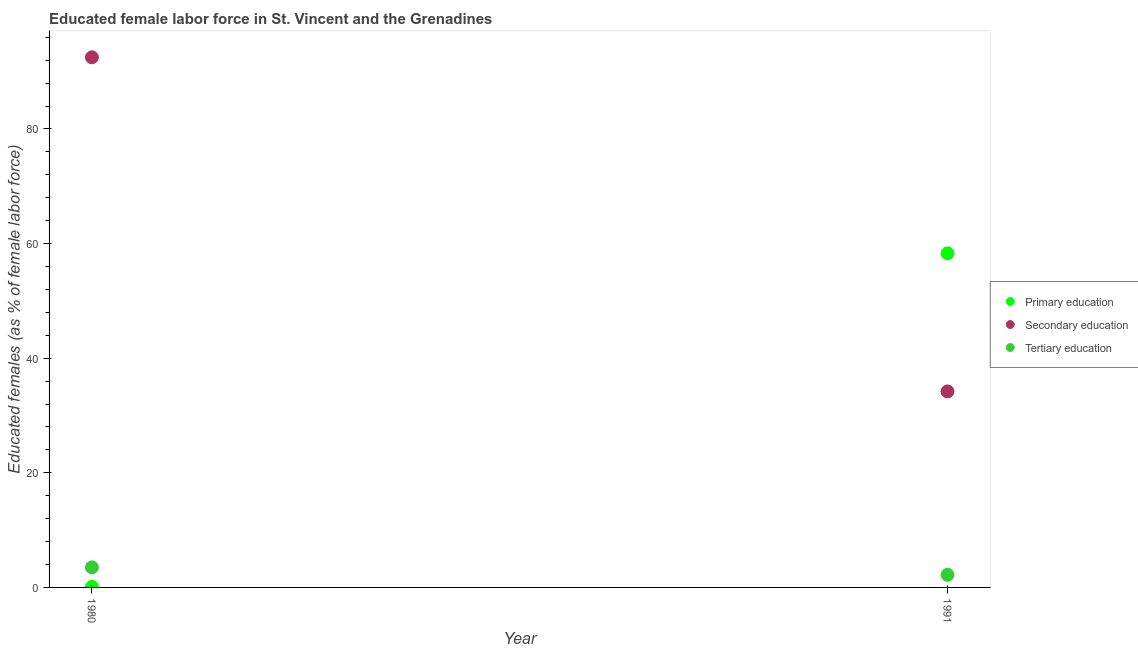How many different coloured dotlines are there?
Give a very brief answer. 3. What is the percentage of female labor force who received primary education in 1980?
Keep it short and to the point. 0.1. Across all years, what is the maximum percentage of female labor force who received secondary education?
Make the answer very short. 92.5. Across all years, what is the minimum percentage of female labor force who received primary education?
Ensure brevity in your answer.  0.1. In which year was the percentage of female labor force who received tertiary education maximum?
Your answer should be compact. 1980. In which year was the percentage of female labor force who received secondary education minimum?
Offer a terse response. 1991. What is the total percentage of female labor force who received primary education in the graph?
Make the answer very short. 58.4. What is the difference between the percentage of female labor force who received primary education in 1980 and that in 1991?
Offer a very short reply. -58.2. What is the difference between the percentage of female labor force who received tertiary education in 1980 and the percentage of female labor force who received secondary education in 1991?
Provide a succinct answer. -30.7. What is the average percentage of female labor force who received secondary education per year?
Your response must be concise. 63.35. In the year 1980, what is the difference between the percentage of female labor force who received primary education and percentage of female labor force who received secondary education?
Offer a very short reply. -92.4. What is the ratio of the percentage of female labor force who received primary education in 1980 to that in 1991?
Ensure brevity in your answer.  0. Is the percentage of female labor force who received secondary education in 1980 less than that in 1991?
Provide a short and direct response. No. In how many years, is the percentage of female labor force who received primary education greater than the average percentage of female labor force who received primary education taken over all years?
Your answer should be very brief. 1. Is it the case that in every year, the sum of the percentage of female labor force who received primary education and percentage of female labor force who received secondary education is greater than the percentage of female labor force who received tertiary education?
Provide a succinct answer. Yes. Does the percentage of female labor force who received secondary education monotonically increase over the years?
Provide a succinct answer. No. Is the percentage of female labor force who received tertiary education strictly greater than the percentage of female labor force who received primary education over the years?
Keep it short and to the point. No. Is the percentage of female labor force who received secondary education strictly less than the percentage of female labor force who received tertiary education over the years?
Offer a very short reply. No. How many dotlines are there?
Provide a short and direct response. 3. What is the difference between two consecutive major ticks on the Y-axis?
Offer a terse response. 20. Where does the legend appear in the graph?
Offer a very short reply. Center right. How are the legend labels stacked?
Offer a terse response. Vertical. What is the title of the graph?
Your answer should be compact. Educated female labor force in St. Vincent and the Grenadines. What is the label or title of the X-axis?
Your answer should be very brief. Year. What is the label or title of the Y-axis?
Make the answer very short. Educated females (as % of female labor force). What is the Educated females (as % of female labor force) of Primary education in 1980?
Provide a short and direct response. 0.1. What is the Educated females (as % of female labor force) of Secondary education in 1980?
Keep it short and to the point. 92.5. What is the Educated females (as % of female labor force) in Primary education in 1991?
Offer a very short reply. 58.3. What is the Educated females (as % of female labor force) of Secondary education in 1991?
Your answer should be compact. 34.2. What is the Educated females (as % of female labor force) of Tertiary education in 1991?
Ensure brevity in your answer.  2.2. Across all years, what is the maximum Educated females (as % of female labor force) of Primary education?
Provide a short and direct response. 58.3. Across all years, what is the maximum Educated females (as % of female labor force) in Secondary education?
Give a very brief answer. 92.5. Across all years, what is the maximum Educated females (as % of female labor force) in Tertiary education?
Your answer should be compact. 3.5. Across all years, what is the minimum Educated females (as % of female labor force) of Primary education?
Make the answer very short. 0.1. Across all years, what is the minimum Educated females (as % of female labor force) in Secondary education?
Your answer should be compact. 34.2. Across all years, what is the minimum Educated females (as % of female labor force) of Tertiary education?
Offer a terse response. 2.2. What is the total Educated females (as % of female labor force) of Primary education in the graph?
Offer a very short reply. 58.4. What is the total Educated females (as % of female labor force) of Secondary education in the graph?
Your answer should be compact. 126.7. What is the difference between the Educated females (as % of female labor force) of Primary education in 1980 and that in 1991?
Provide a short and direct response. -58.2. What is the difference between the Educated females (as % of female labor force) in Secondary education in 1980 and that in 1991?
Make the answer very short. 58.3. What is the difference between the Educated females (as % of female labor force) in Primary education in 1980 and the Educated females (as % of female labor force) in Secondary education in 1991?
Offer a terse response. -34.1. What is the difference between the Educated females (as % of female labor force) of Secondary education in 1980 and the Educated females (as % of female labor force) of Tertiary education in 1991?
Your answer should be very brief. 90.3. What is the average Educated females (as % of female labor force) in Primary education per year?
Provide a succinct answer. 29.2. What is the average Educated females (as % of female labor force) of Secondary education per year?
Keep it short and to the point. 63.35. What is the average Educated females (as % of female labor force) of Tertiary education per year?
Your response must be concise. 2.85. In the year 1980, what is the difference between the Educated females (as % of female labor force) in Primary education and Educated females (as % of female labor force) in Secondary education?
Make the answer very short. -92.4. In the year 1980, what is the difference between the Educated females (as % of female labor force) of Primary education and Educated females (as % of female labor force) of Tertiary education?
Ensure brevity in your answer.  -3.4. In the year 1980, what is the difference between the Educated females (as % of female labor force) of Secondary education and Educated females (as % of female labor force) of Tertiary education?
Your answer should be compact. 89. In the year 1991, what is the difference between the Educated females (as % of female labor force) in Primary education and Educated females (as % of female labor force) in Secondary education?
Offer a very short reply. 24.1. In the year 1991, what is the difference between the Educated females (as % of female labor force) of Primary education and Educated females (as % of female labor force) of Tertiary education?
Keep it short and to the point. 56.1. What is the ratio of the Educated females (as % of female labor force) of Primary education in 1980 to that in 1991?
Your answer should be very brief. 0. What is the ratio of the Educated females (as % of female labor force) of Secondary education in 1980 to that in 1991?
Ensure brevity in your answer.  2.7. What is the ratio of the Educated females (as % of female labor force) in Tertiary education in 1980 to that in 1991?
Provide a short and direct response. 1.59. What is the difference between the highest and the second highest Educated females (as % of female labor force) in Primary education?
Offer a terse response. 58.2. What is the difference between the highest and the second highest Educated females (as % of female labor force) of Secondary education?
Provide a short and direct response. 58.3. What is the difference between the highest and the second highest Educated females (as % of female labor force) in Tertiary education?
Provide a short and direct response. 1.3. What is the difference between the highest and the lowest Educated females (as % of female labor force) in Primary education?
Your answer should be very brief. 58.2. What is the difference between the highest and the lowest Educated females (as % of female labor force) in Secondary education?
Keep it short and to the point. 58.3. What is the difference between the highest and the lowest Educated females (as % of female labor force) in Tertiary education?
Keep it short and to the point. 1.3. 